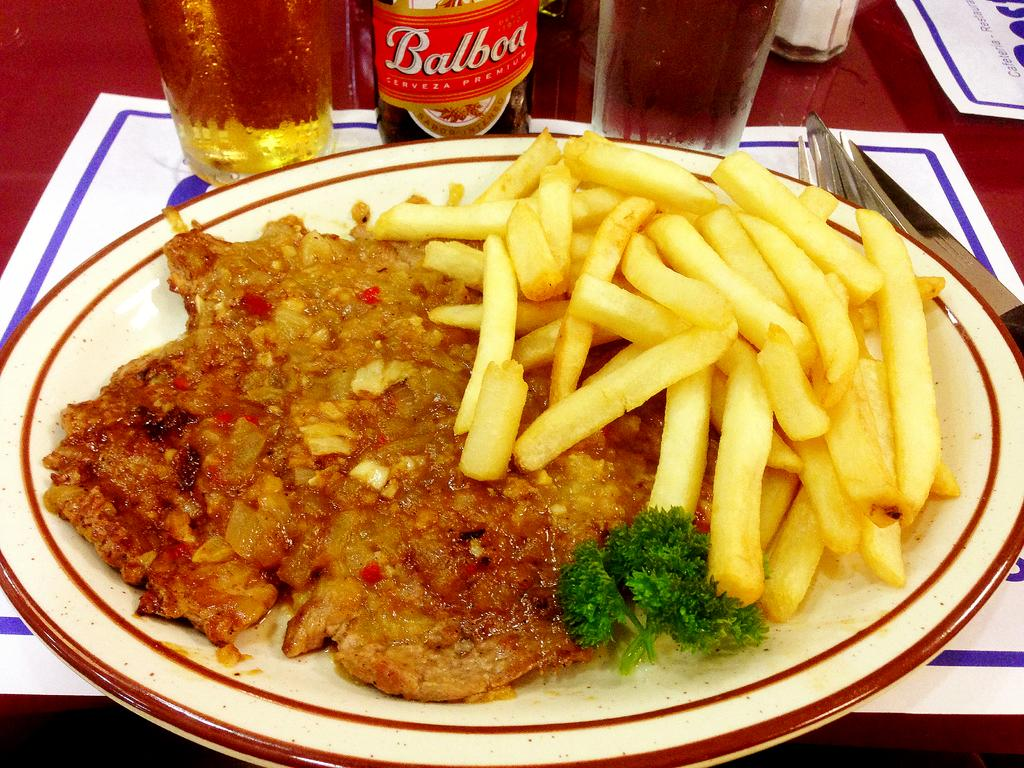What is on the plate in the image? There are food items on a plate in the image. What type of container is visible in the image? There is a bottle in the image. What type of tableware is present in the image? There are glasses, a fork, and a knife in the image. What type of written material is present in the image? There are papers with text in the image. Where are all these items located? All of these items are on a table. Can you tell me how many girls are sitting on the bear in the image? There are no girls or bears present in the image. What type of cart is visible in the image? There is no cart present in the image. 